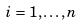Convert formula to latex. <formula><loc_0><loc_0><loc_500><loc_500>i = 1 , \dots , n</formula> 